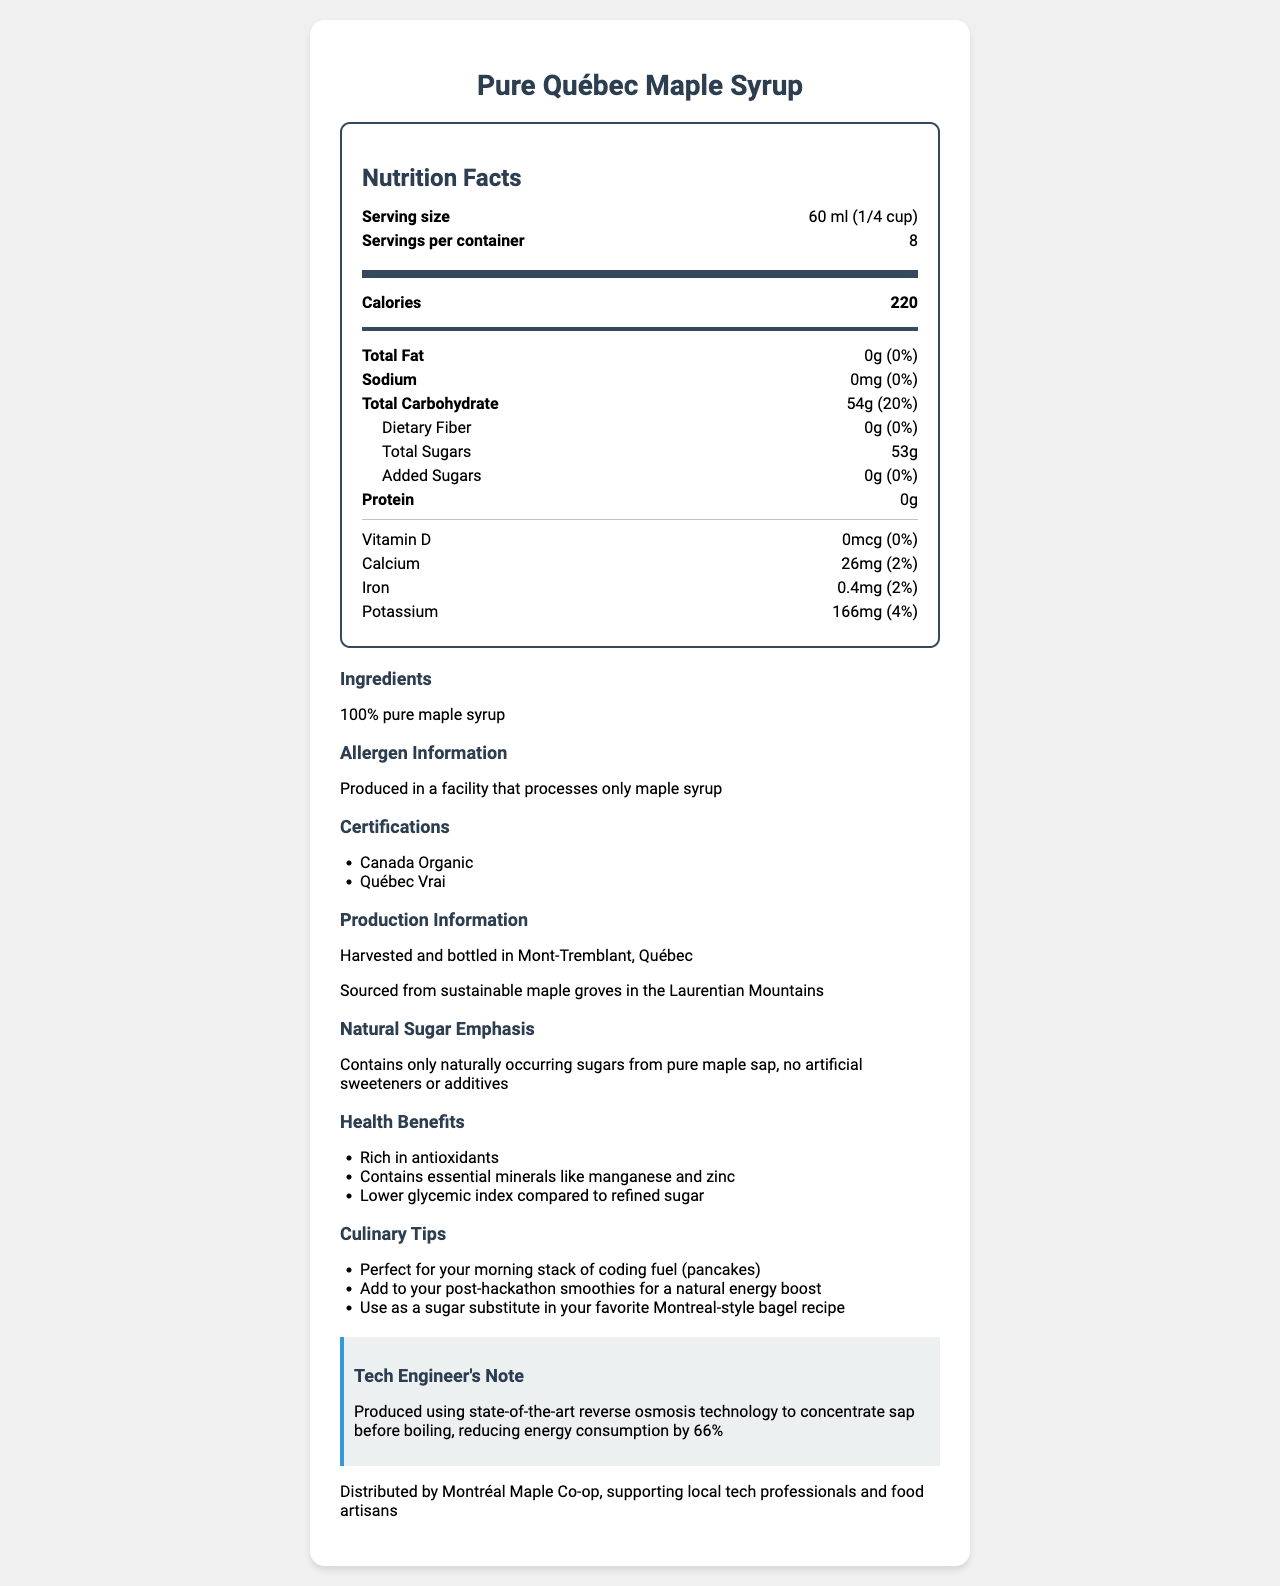what is the serving size of the Pure Québec Maple Syrup? The serving size is listed at the top of the Nutrition Facts section.
Answer: 60 ml (1/4 cup) how many calories are there per serving? The document specifies 220 calories per serving in the Nutrition Facts section.
Answer: 220 what is the total carbohydrate content per serving? The total carbohydrate amount is listed under the Total Carbohydrate section as 54g.
Answer: 54g are there any added sugars in the Pure Québec Maple Syrup? The document explicitly states that there are 0g of added sugars.
Answer: No what essential minerals does the Pure Québec Maple Syrup contain? The document lists Calcium (26mg), Iron (0.4mg), Potassium (166mg) under the Nutrition Facts and mentions Manganese and Zinc under health benefits.
Answer: Calcium, Iron, Potassium, Manganese, Zinc what is the company that distributes the Pure Québec Maple Syrup? A. Canada Maple Co-op B. Montréal Maple Co-op C. Québec Maple Co-op The distribution info mentions that it is distributed by Montréal Maple Co-op.
Answer: B what certifications does this maple syrup have? A. Canada Organic B. Québec Vrai C. Non-GMO Project Verified D. Only A and B E. All of the above The certifications listed are Canada Organic and Québec Vrai.
Answer: D is there any protein content in the Pure Québec Maple Syrup? The document mentions that there is 0g of protein per serving.
Answer: No are there any common allergens in this product? The allergen information states that it is produced in a facility that processes only maple syrup.
Answer: No what technology is used in the production of this maple syrup to reduce energy consumption? The tech engineer’s note mentions the use of state-of-the-art reverse osmosis technology to concentrate sap before boiling, reducing energy consumption by 66%.
Answer: Reverse osmosis technology can this maple syrup be used as a substitute in a Montreal-style bagel recipe? The document provides a culinary tip mentioning to use it as a sugar substitute in your favorite Montreal-style bagel recipe.
Answer: Yes what other health benefits does the Pure Québec Maple Syrup provide? Health benefits are listed under a dedicated health benefits section.
Answer: Rich in antioxidants, Contains essential minerals like manganese and zinc, Lower glycemic index compared to refined sugar summarize the main idea of the document. The document covers various aspects of the Pure Québec Maple Syrup, including detailed nutrition information, ingredient purity, allergen safety, health advantages, production techniques, certification standards, sustainability, and local distribution. It also offers culinary tips and underscores significant points of interest for both general consumers and tech-savvy professionals.
Answer: The document provides the nutrition facts, ingredients, certifications, and production information of Pure Québec Maple Syrup, emphasizing its natural sugar content, health benefits, and sustainable production practices. Additionally, it highlights its use of advanced technology and connection to the local community in Montreal. where can I buy this maple syrup in Vancouver? The document provides information about the distribution by Montréal Maple Co-op but doesn’t specify availability in other locations like Vancouver.
Answer: Not enough information 